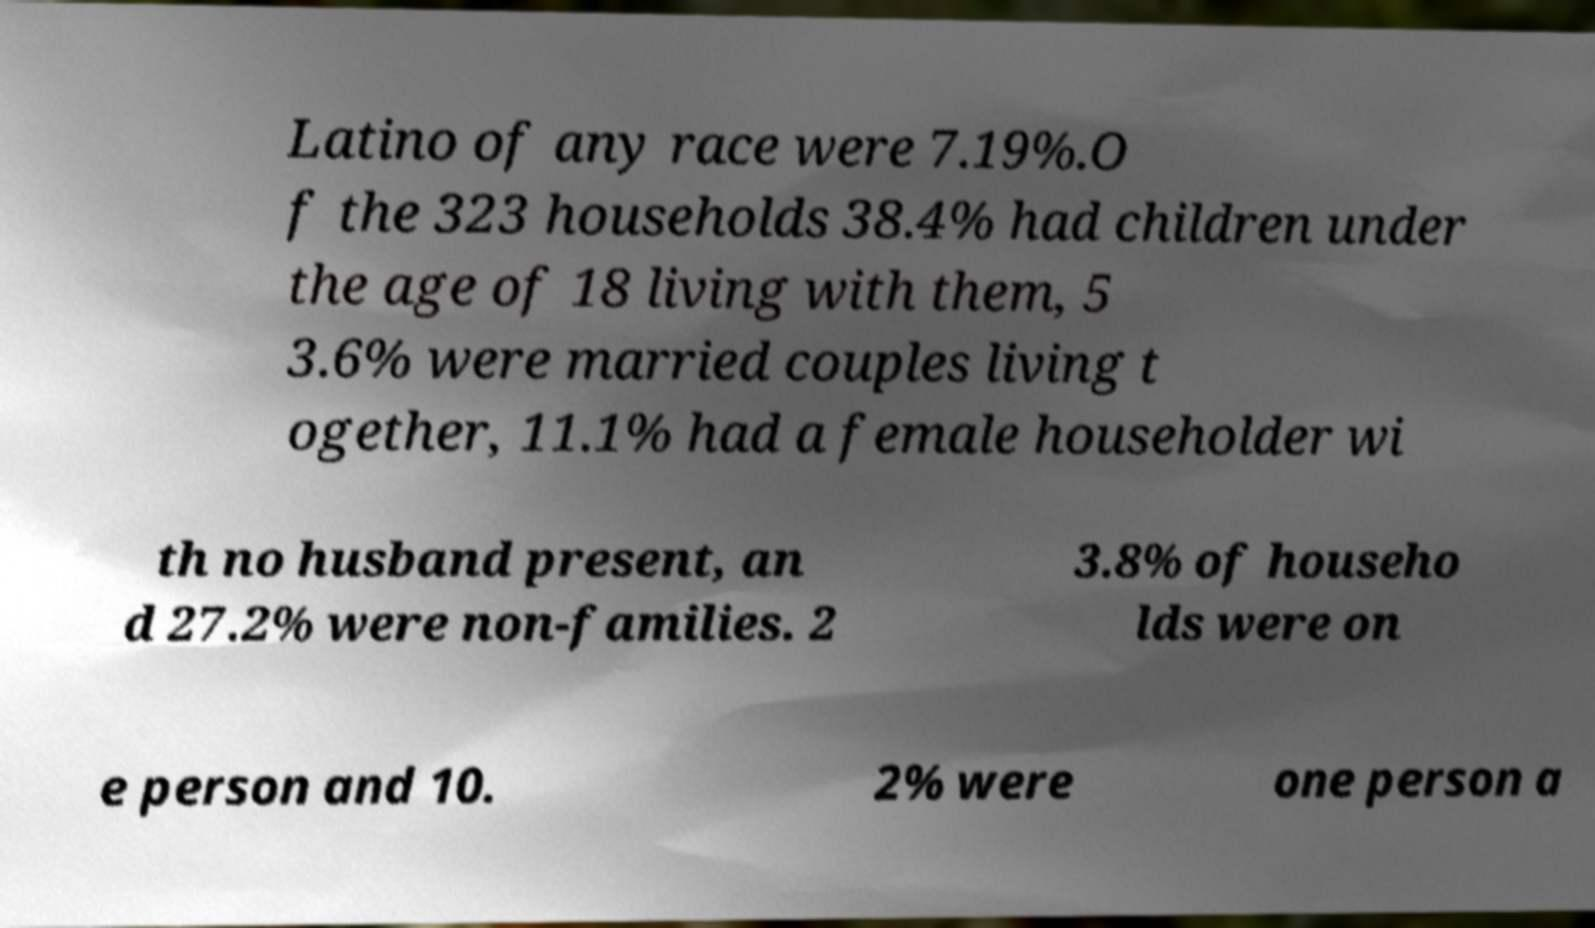Could you extract and type out the text from this image? Latino of any race were 7.19%.O f the 323 households 38.4% had children under the age of 18 living with them, 5 3.6% were married couples living t ogether, 11.1% had a female householder wi th no husband present, an d 27.2% were non-families. 2 3.8% of househo lds were on e person and 10. 2% were one person a 